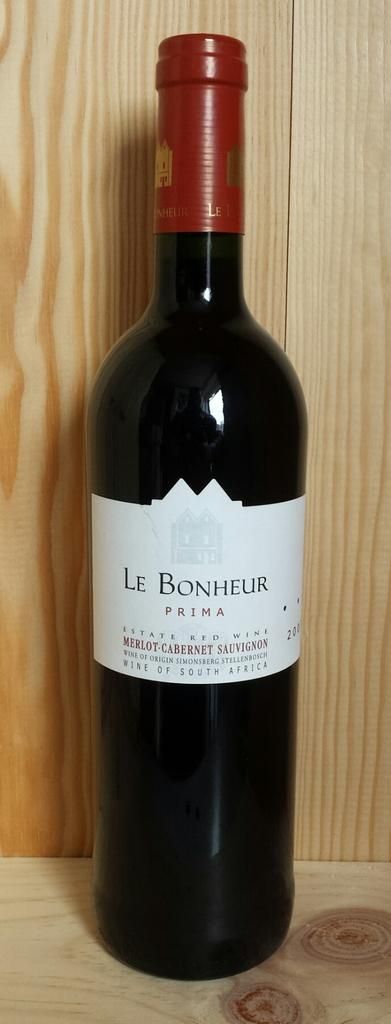Provide a one-sentence caption for the provided image. A bottle of Le Bonheur Prima Estate Red Wine. 